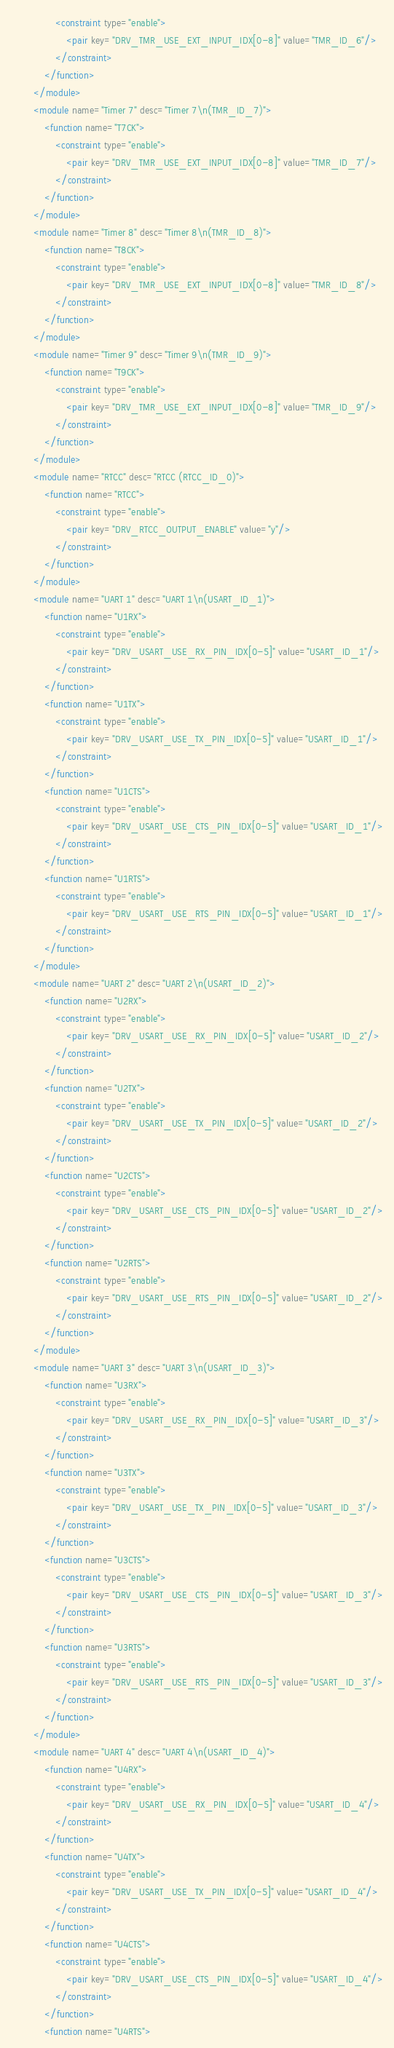<code> <loc_0><loc_0><loc_500><loc_500><_XML_>                <constraint type="enable">
                    <pair key="DRV_TMR_USE_EXT_INPUT_IDX[0-8]" value="TMR_ID_6"/>
                </constraint>
            </function>
        </module>
        <module name="Timer 7" desc="Timer 7\n(TMR_ID_7)">
            <function name="T7CK">
                <constraint type="enable">
                    <pair key="DRV_TMR_USE_EXT_INPUT_IDX[0-8]" value="TMR_ID_7"/>
                </constraint>
            </function>
        </module>
        <module name="Timer 8" desc="Timer 8\n(TMR_ID_8)">
            <function name="T8CK">
                <constraint type="enable">
                    <pair key="DRV_TMR_USE_EXT_INPUT_IDX[0-8]" value="TMR_ID_8"/>
                </constraint>
            </function>
        </module>
        <module name="Timer 9" desc="Timer 9\n(TMR_ID_9)">
            <function name="T9CK">
                <constraint type="enable">
                    <pair key="DRV_TMR_USE_EXT_INPUT_IDX[0-8]" value="TMR_ID_9"/>
                </constraint>
            </function>
        </module>
        <module name="RTCC" desc="RTCC (RTCC_ID_0)">
            <function name="RTCC">
                <constraint type="enable">
                    <pair key="DRV_RTCC_OUTPUT_ENABLE" value="y"/>
                </constraint>
            </function>
        </module>
        <module name="UART 1" desc="UART 1\n(USART_ID_1)">
            <function name="U1RX">
                <constraint type="enable">
                    <pair key="DRV_USART_USE_RX_PIN_IDX[0-5]" value="USART_ID_1"/>
                </constraint>
            </function>
            <function name="U1TX">
                <constraint type="enable">
                    <pair key="DRV_USART_USE_TX_PIN_IDX[0-5]" value="USART_ID_1"/>
                </constraint>
            </function>
            <function name="U1CTS">
                <constraint type="enable">
                    <pair key="DRV_USART_USE_CTS_PIN_IDX[0-5]" value="USART_ID_1"/>
                </constraint>
            </function>
            <function name="U1RTS">
                <constraint type="enable">
                    <pair key="DRV_USART_USE_RTS_PIN_IDX[0-5]" value="USART_ID_1"/>
                </constraint>
            </function>
        </module>
        <module name="UART 2" desc="UART 2\n(USART_ID_2)">
            <function name="U2RX">
                <constraint type="enable">
                    <pair key="DRV_USART_USE_RX_PIN_IDX[0-5]" value="USART_ID_2"/>
                </constraint>
            </function>
            <function name="U2TX">
                <constraint type="enable">
                    <pair key="DRV_USART_USE_TX_PIN_IDX[0-5]" value="USART_ID_2"/>
                </constraint>
            </function>
            <function name="U2CTS">
                <constraint type="enable">
                    <pair key="DRV_USART_USE_CTS_PIN_IDX[0-5]" value="USART_ID_2"/>
                </constraint>
            </function>
            <function name="U2RTS">
                <constraint type="enable">
                    <pair key="DRV_USART_USE_RTS_PIN_IDX[0-5]" value="USART_ID_2"/>
                </constraint>
            </function>
        </module>
        <module name="UART 3" desc="UART 3\n(USART_ID_3)">
            <function name="U3RX">
                <constraint type="enable">
                    <pair key="DRV_USART_USE_RX_PIN_IDX[0-5]" value="USART_ID_3"/>
                </constraint>
            </function>
            <function name="U3TX">
                <constraint type="enable">
                    <pair key="DRV_USART_USE_TX_PIN_IDX[0-5]" value="USART_ID_3"/>
                </constraint>
            </function>
            <function name="U3CTS">
                <constraint type="enable">
                    <pair key="DRV_USART_USE_CTS_PIN_IDX[0-5]" value="USART_ID_3"/>
                </constraint>
            </function>
            <function name="U3RTS">
                <constraint type="enable">
                    <pair key="DRV_USART_USE_RTS_PIN_IDX[0-5]" value="USART_ID_3"/>
                </constraint>
            </function>
        </module>
        <module name="UART 4" desc="UART 4\n(USART_ID_4)">
            <function name="U4RX">
                <constraint type="enable">
                    <pair key="DRV_USART_USE_RX_PIN_IDX[0-5]" value="USART_ID_4"/>
                </constraint>
            </function>
            <function name="U4TX">
                <constraint type="enable">
                    <pair key="DRV_USART_USE_TX_PIN_IDX[0-5]" value="USART_ID_4"/>
                </constraint>
            </function>
            <function name="U4CTS">
                <constraint type="enable">
                    <pair key="DRV_USART_USE_CTS_PIN_IDX[0-5]" value="USART_ID_4"/>
                </constraint>
            </function>
            <function name="U4RTS"></code> 